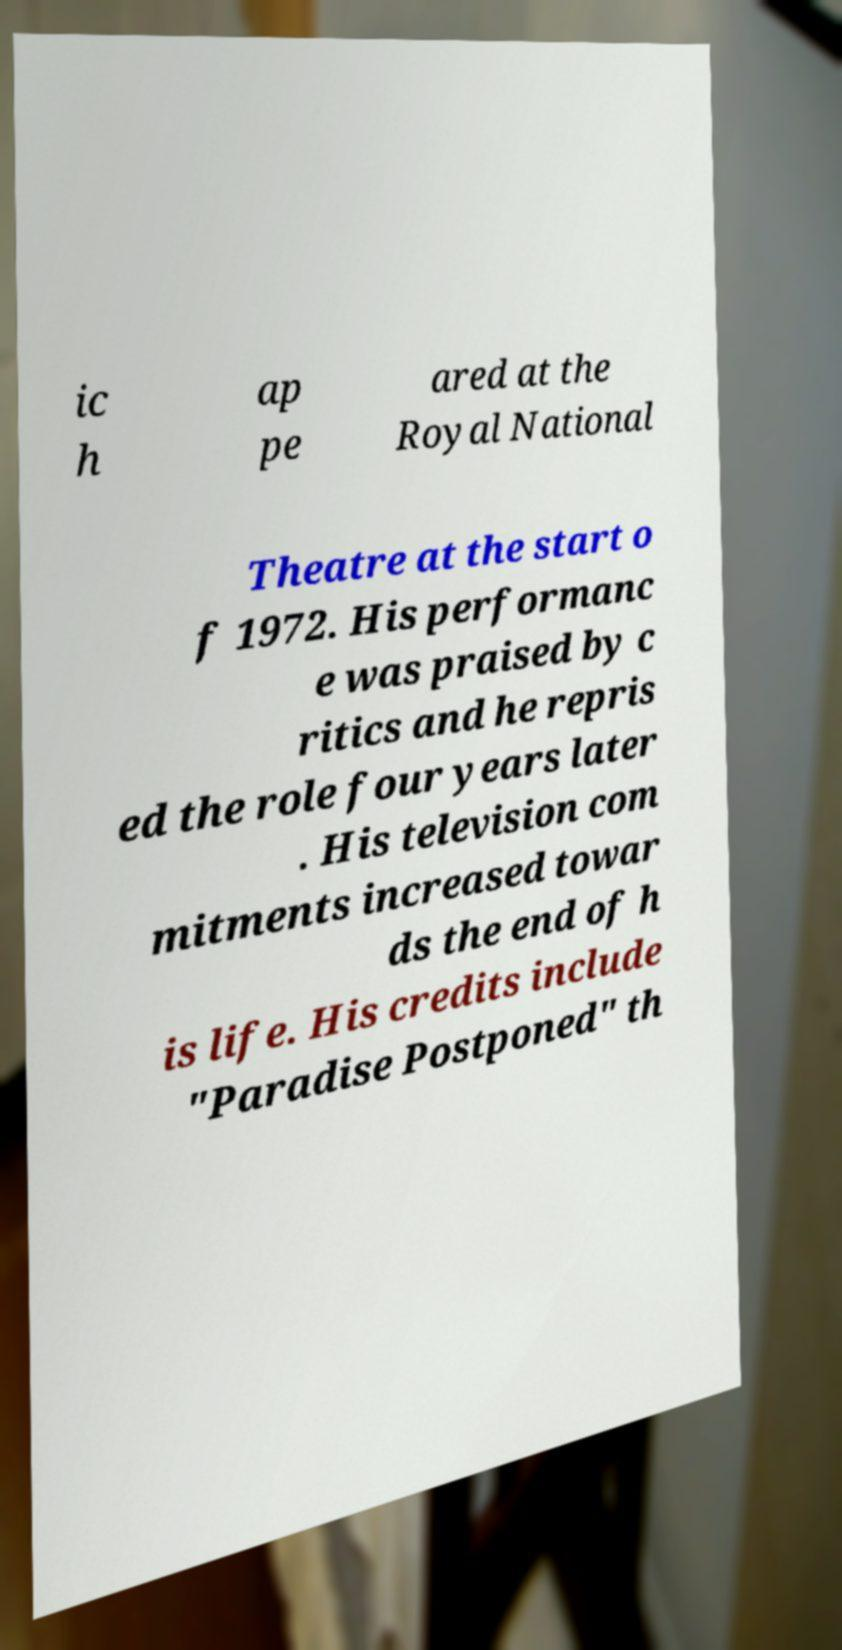Could you assist in decoding the text presented in this image and type it out clearly? ic h ap pe ared at the Royal National Theatre at the start o f 1972. His performanc e was praised by c ritics and he repris ed the role four years later . His television com mitments increased towar ds the end of h is life. His credits include "Paradise Postponed" th 